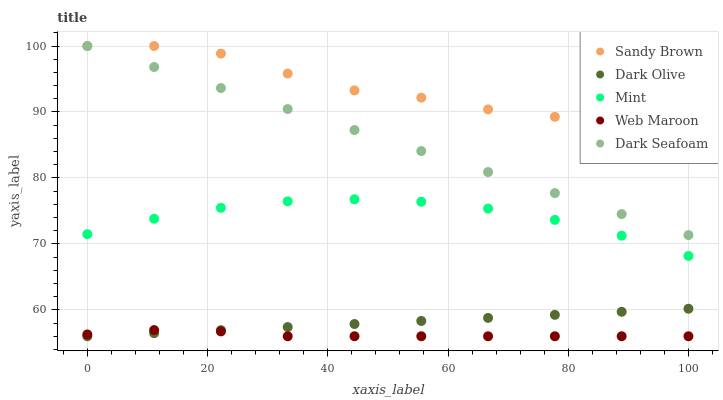Does Web Maroon have the minimum area under the curve?
Answer yes or no. Yes. Does Sandy Brown have the maximum area under the curve?
Answer yes or no. Yes. Does Dark Seafoam have the minimum area under the curve?
Answer yes or no. No. Does Dark Seafoam have the maximum area under the curve?
Answer yes or no. No. Is Dark Olive the smoothest?
Answer yes or no. Yes. Is Sandy Brown the roughest?
Answer yes or no. Yes. Is Dark Seafoam the smoothest?
Answer yes or no. No. Is Dark Seafoam the roughest?
Answer yes or no. No. Does Dark Olive have the lowest value?
Answer yes or no. Yes. Does Dark Seafoam have the lowest value?
Answer yes or no. No. Does Sandy Brown have the highest value?
Answer yes or no. Yes. Does Dark Olive have the highest value?
Answer yes or no. No. Is Dark Olive less than Dark Seafoam?
Answer yes or no. Yes. Is Dark Seafoam greater than Web Maroon?
Answer yes or no. Yes. Does Sandy Brown intersect Dark Seafoam?
Answer yes or no. Yes. Is Sandy Brown less than Dark Seafoam?
Answer yes or no. No. Is Sandy Brown greater than Dark Seafoam?
Answer yes or no. No. Does Dark Olive intersect Dark Seafoam?
Answer yes or no. No. 